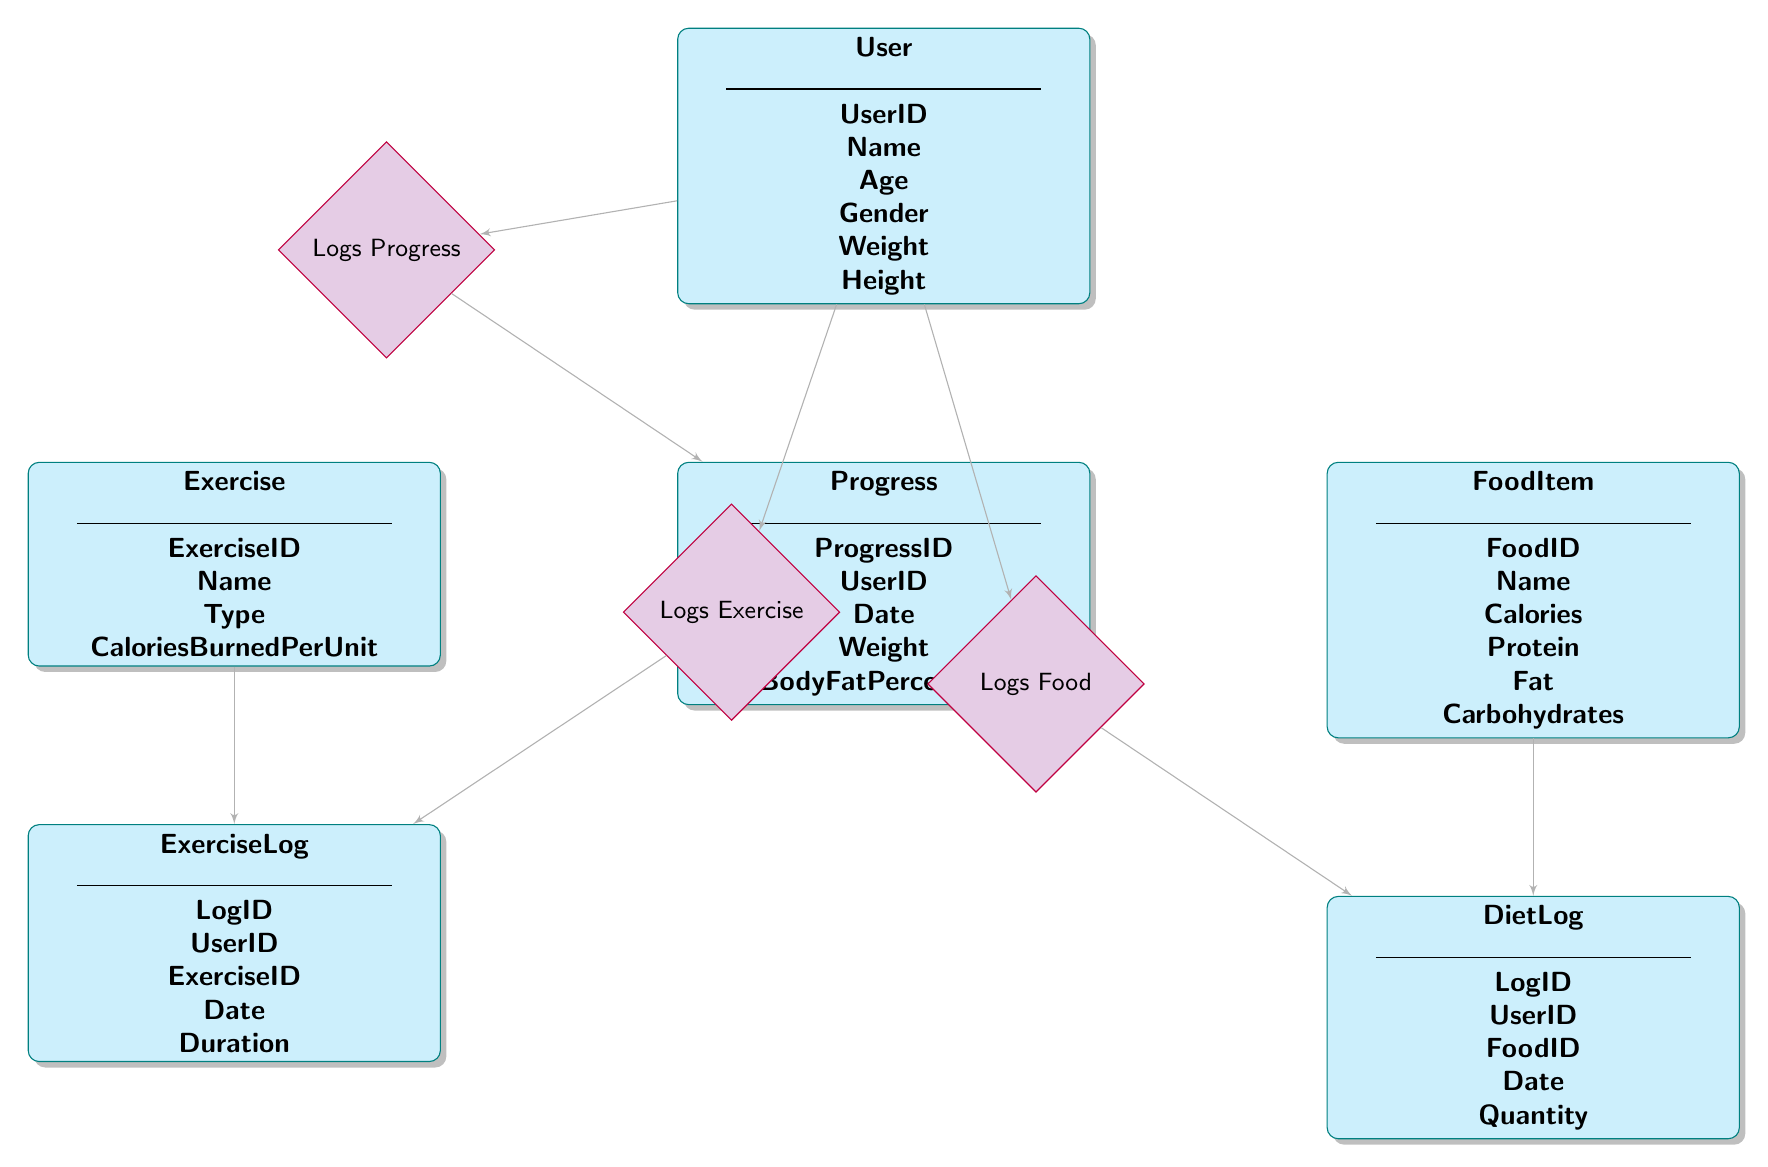What is the primary key of the User entity? The primary key of the User entity is indicated by "UserID" in the diagram, which uniquely identifies each user.
Answer: UserID How many entities are there in the diagram? In the diagram, there are a total of six entities: User, Exercise, ExerciseLog, FoodItem, DietLog, and Progress.
Answer: 6 What does the ExerciseLog entity track? The ExerciseLog entity tracks information related to exercises logged by users, including UserID, ExerciseID, Date, and Duration.
Answer: Exercises Which relationship connects the DietLog and the User entities? The relationship that connects the DietLog and the User entities is named "Logs Food," indicating that the user logs food items.
Answer: Logs Food How many foreign keys does the DietLog entity have? The DietLog entity contains two foreign keys: UserID and FoodID, linking it to the User and FoodItem entities respectively.
Answer: 2 What type of information does the Progress entity store? The Progress entity stores information related to user progress, including UserID, Date, Weight, and BodyFatPercentage.
Answer: User progress Which entity includes the attribute "CaloriesBurnedPerUnit"? The attribute "CaloriesBurnedPerUnit" is included in the Exercise entity, providing details about the calories burned during exercises.
Answer: Exercise How is the ExerciseLog related to the User entity? The ExerciseLog is related to the User entity through the "Logs Exercise" relationship, showing which user logged each exercise.
Answer: Logs Exercise How many relationships are shown in the diagram? There are three relationships shown in the diagram: Logs Exercise, Logs Food, and Logs Progress, each linking entities together.
Answer: 3 